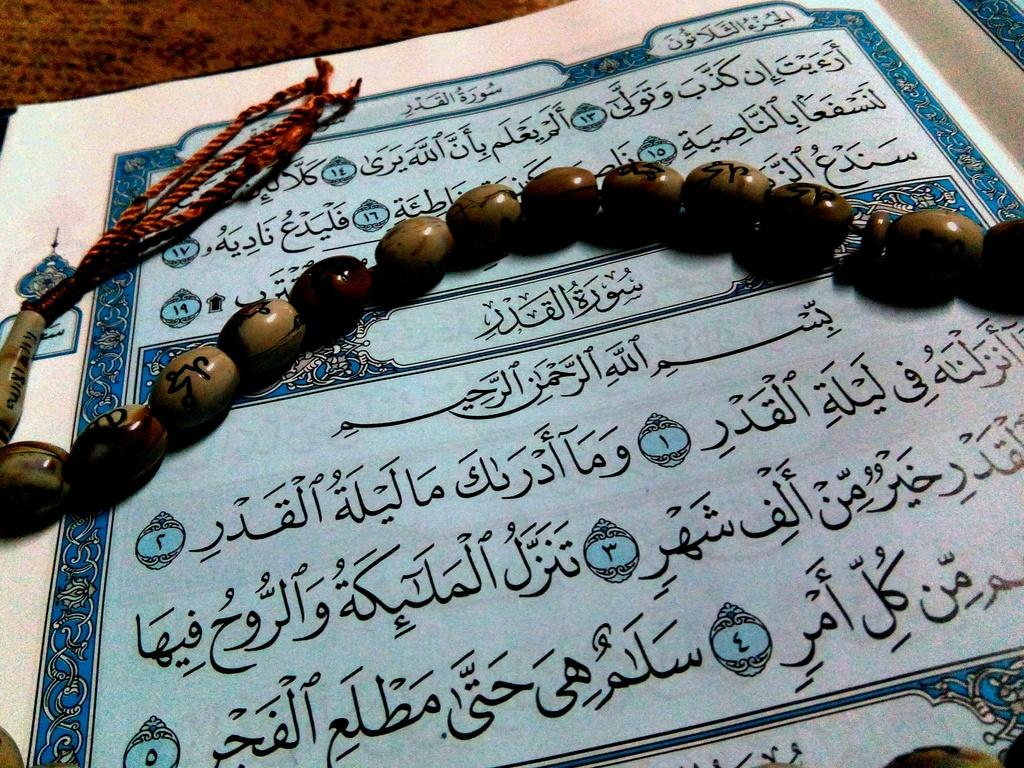What is on the paper that is visible in the image? There is text on the paper in the image. Where is the paper located in the image? The paper is placed on a surface in the image. What is the decorative element on the paper? There is a band made with beads and thread on the paper. How many bushes are visible in the image? There are no bushes visible in the image; it only features a paper with text and a decorative band. What type of ring is the person wearing in the image? There is no person or ring present in the image. 